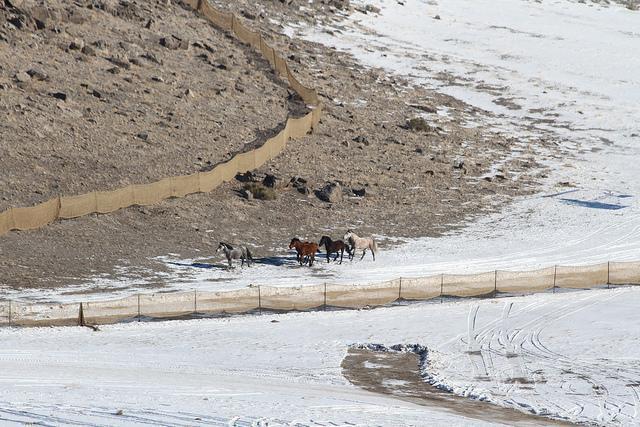How many people are to the left of the cats?
Give a very brief answer. 0. 